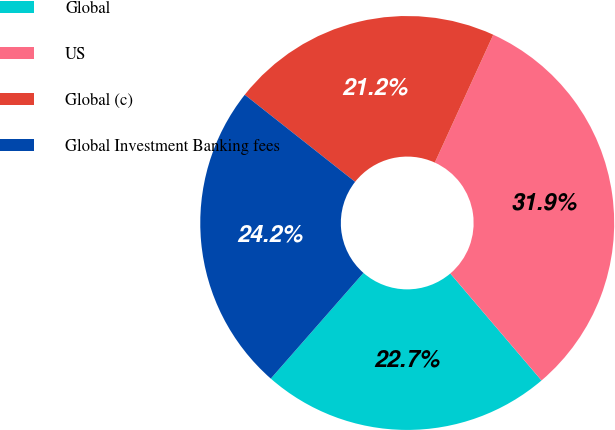<chart> <loc_0><loc_0><loc_500><loc_500><pie_chart><fcel>Global<fcel>US<fcel>Global (c)<fcel>Global Investment Banking fees<nl><fcel>22.69%<fcel>31.94%<fcel>21.19%<fcel>24.18%<nl></chart> 